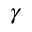Convert formula to latex. <formula><loc_0><loc_0><loc_500><loc_500>\gamma</formula> 